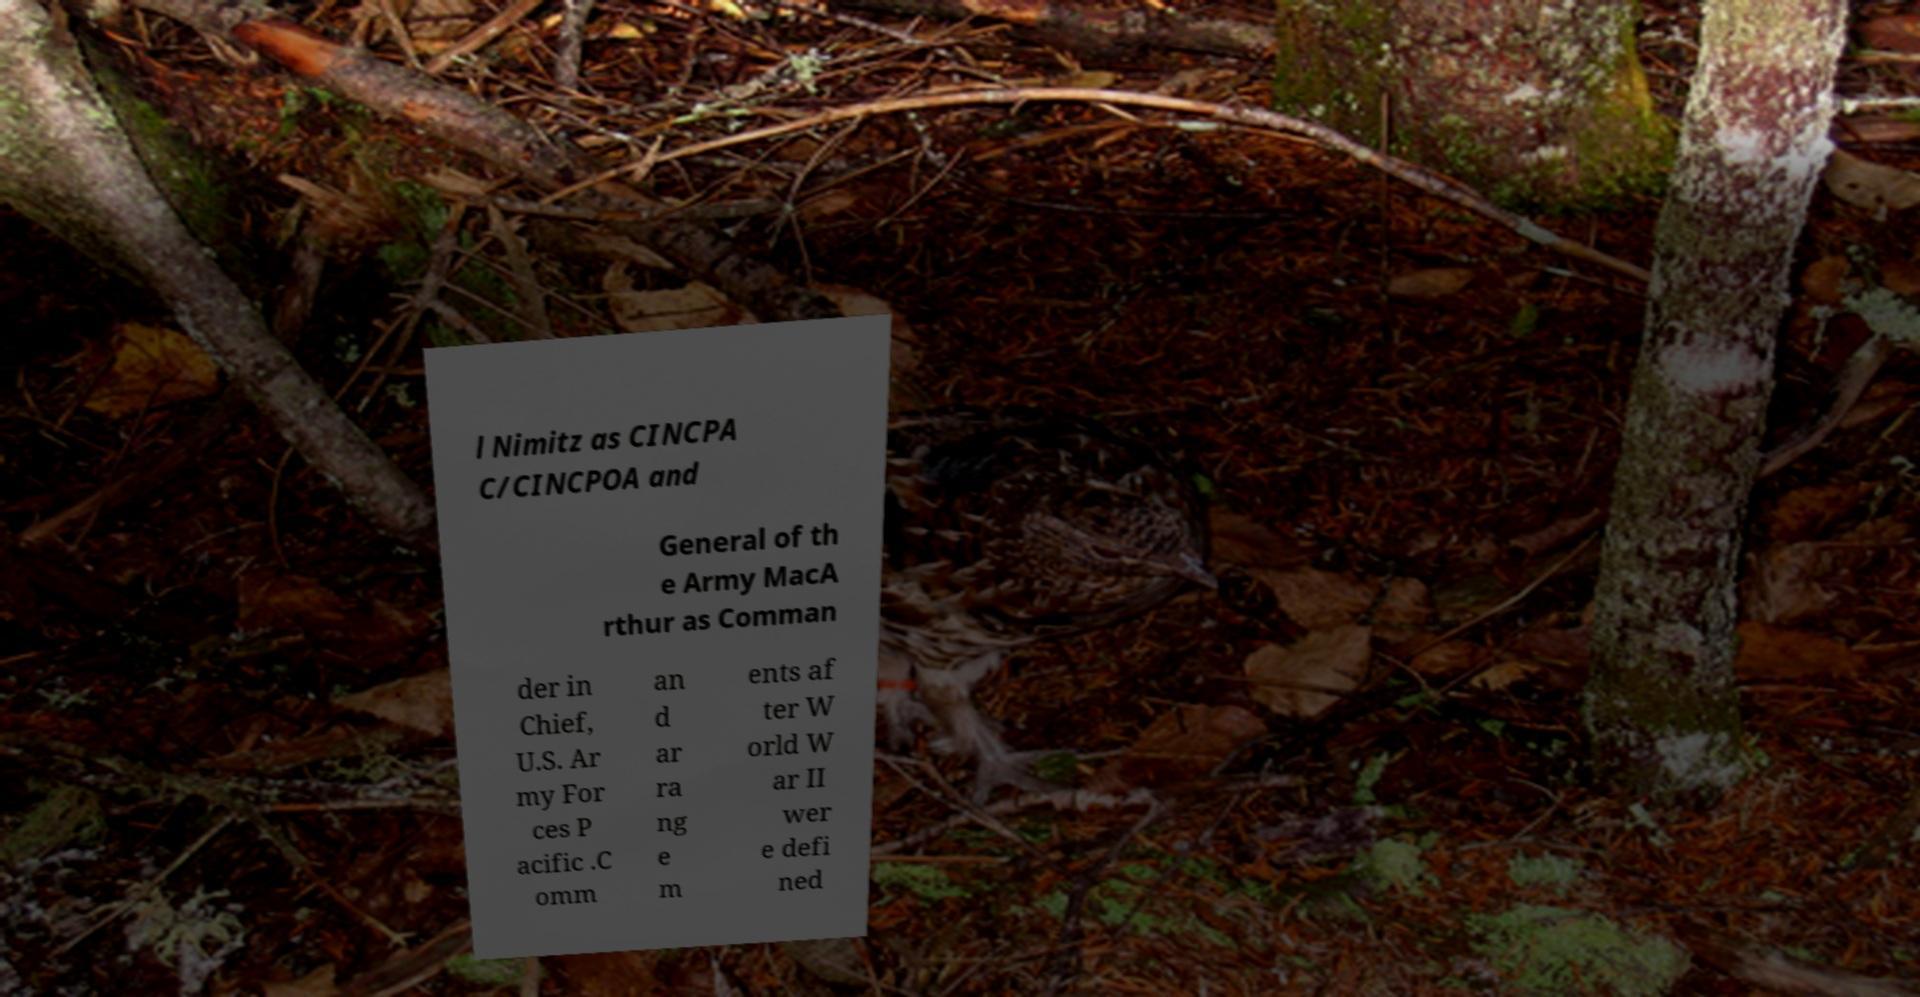Could you assist in decoding the text presented in this image and type it out clearly? l Nimitz as CINCPA C/CINCPOA and General of th e Army MacA rthur as Comman der in Chief, U.S. Ar my For ces P acific .C omm an d ar ra ng e m ents af ter W orld W ar II wer e defi ned 